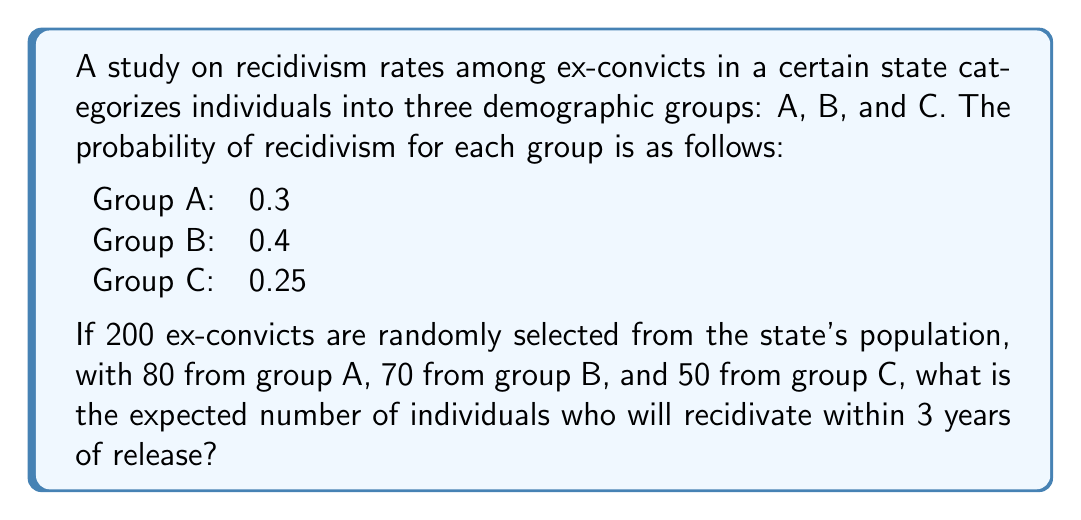Could you help me with this problem? To solve this problem, we need to calculate the expected number of recidivists for each group and then sum them up. Let's break it down step-by-step:

1. For Group A:
   - Number of individuals: 80
   - Probability of recidivism: 0.3
   - Expected number of recidivists: $E(A) = 80 \times 0.3 = 24$

2. For Group B:
   - Number of individuals: 70
   - Probability of recidivism: 0.4
   - Expected number of recidivists: $E(B) = 70 \times 0.4 = 28$

3. For Group C:
   - Number of individuals: 50
   - Probability of recidivism: 0.25
   - Expected number of recidivists: $E(C) = 50 \times 0.25 = 12.5$

4. Total expected number of recidivists:
   $E(\text{Total}) = E(A) + E(B) + E(C)$
   $E(\text{Total}) = 24 + 28 + 12.5 = 64.5$

Therefore, the expected number of individuals who will recidivate within 3 years of release is 64.5.
Answer: 64.5 